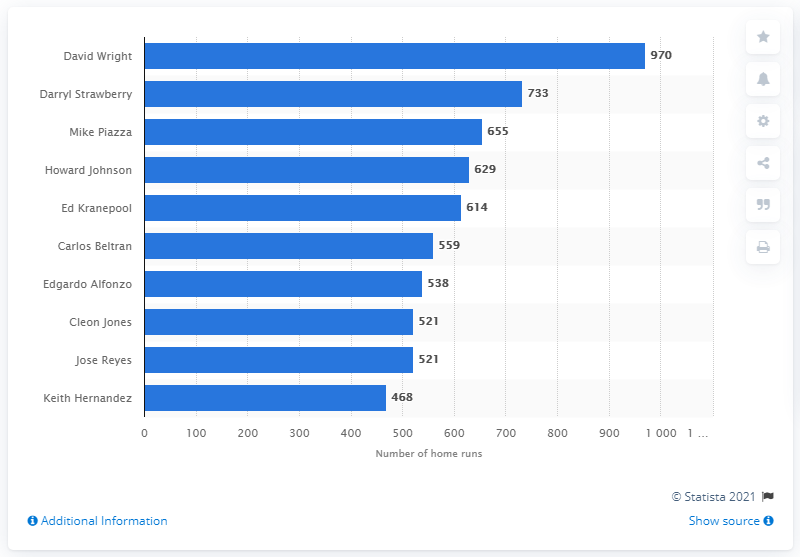Outline some significant characteristics in this image. To date, David Wright has batted a total of 970 times. David Wright holds the record for the most RBI in New York Mets franchise history. 